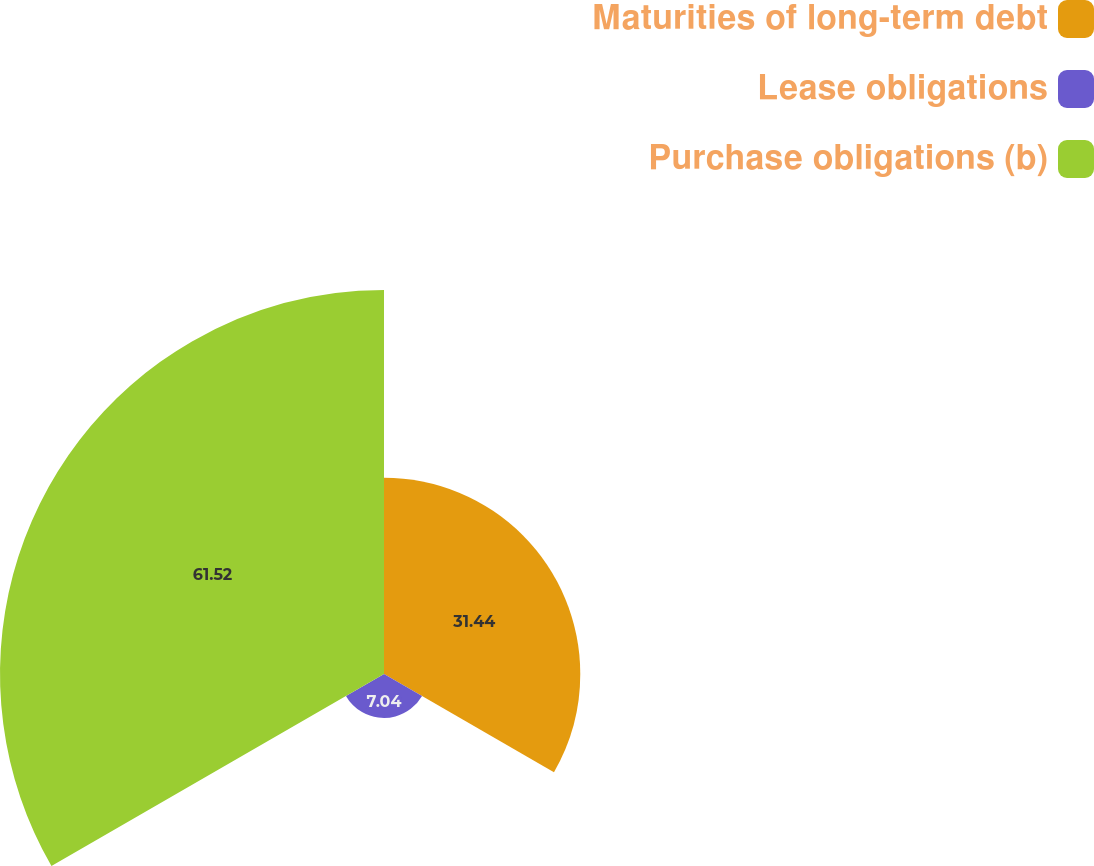<chart> <loc_0><loc_0><loc_500><loc_500><pie_chart><fcel>Maturities of long-term debt<fcel>Lease obligations<fcel>Purchase obligations (b)<nl><fcel>31.44%<fcel>7.04%<fcel>61.51%<nl></chart> 